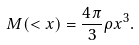<formula> <loc_0><loc_0><loc_500><loc_500>M ( < x ) = \frac { 4 \pi } { 3 } \rho x ^ { 3 } .</formula> 